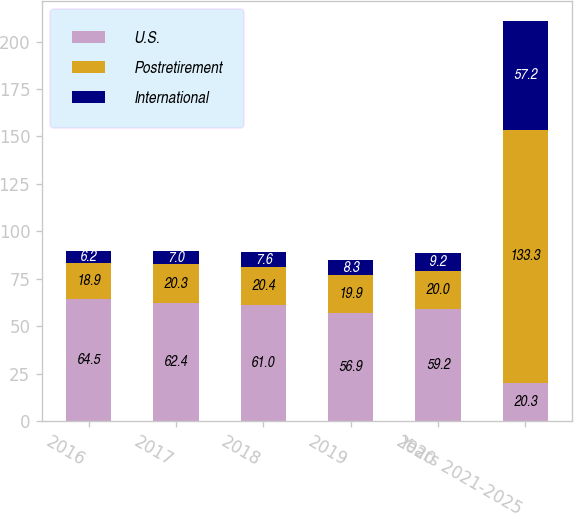Convert chart. <chart><loc_0><loc_0><loc_500><loc_500><stacked_bar_chart><ecel><fcel>2016<fcel>2017<fcel>2018<fcel>2019<fcel>2020<fcel>Years 2021-2025<nl><fcel>U.S.<fcel>64.5<fcel>62.4<fcel>61<fcel>56.9<fcel>59.2<fcel>20.3<nl><fcel>Postretirement<fcel>18.9<fcel>20.3<fcel>20.4<fcel>19.9<fcel>20<fcel>133.3<nl><fcel>International<fcel>6.2<fcel>7<fcel>7.6<fcel>8.3<fcel>9.2<fcel>57.2<nl></chart> 